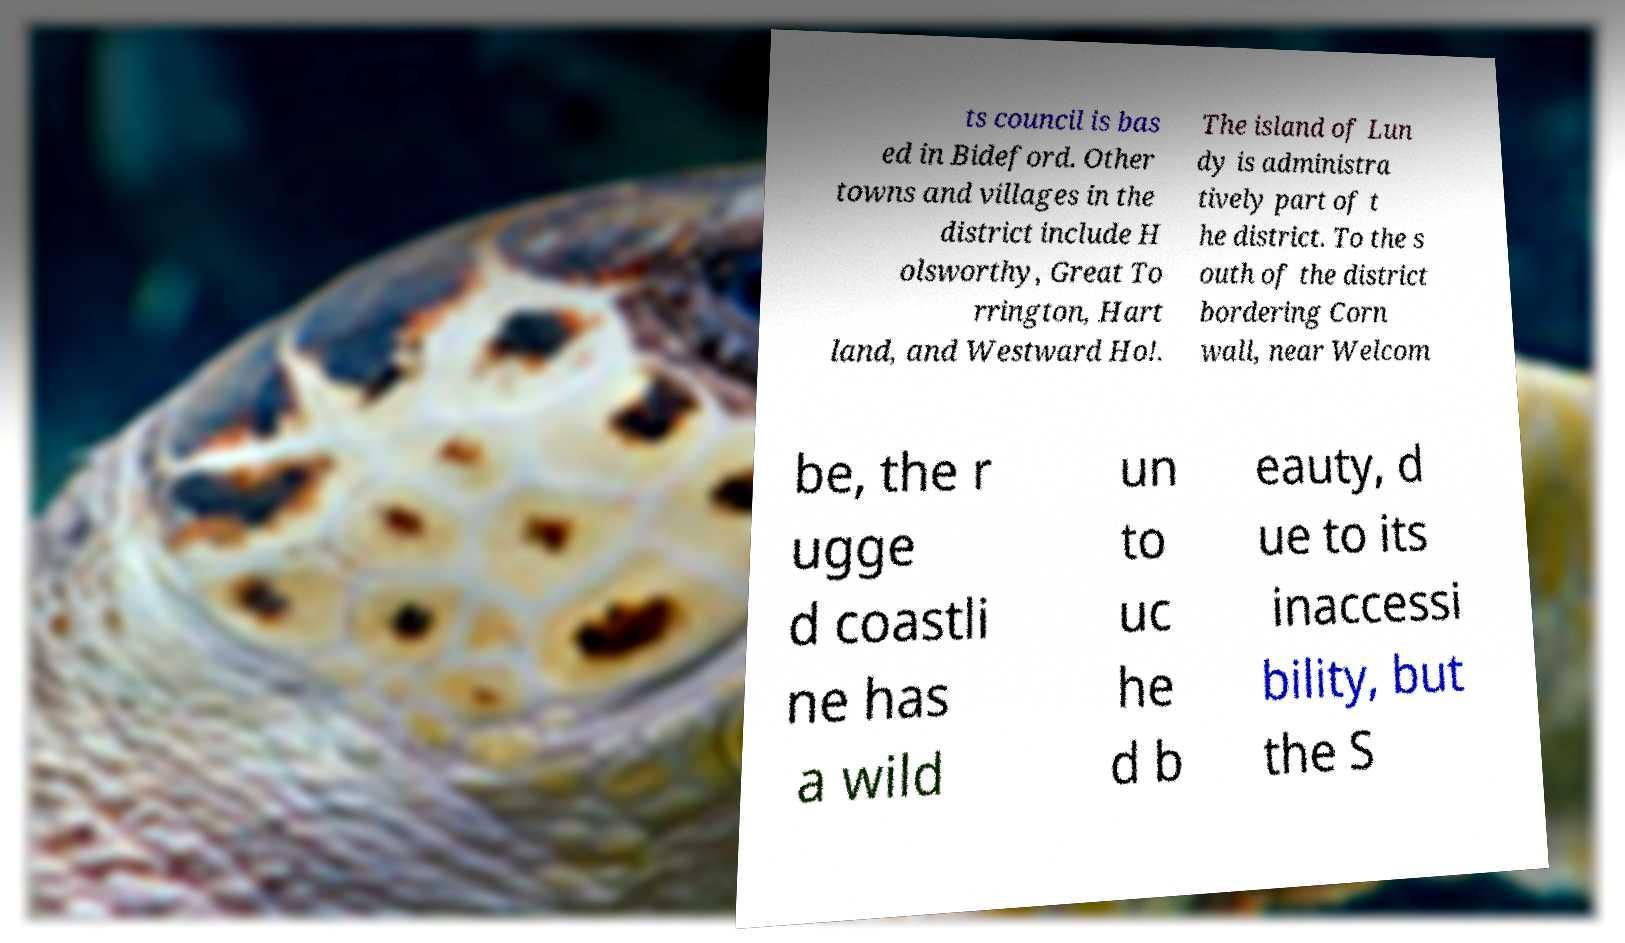What messages or text are displayed in this image? I need them in a readable, typed format. ts council is bas ed in Bideford. Other towns and villages in the district include H olsworthy, Great To rrington, Hart land, and Westward Ho!. The island of Lun dy is administra tively part of t he district. To the s outh of the district bordering Corn wall, near Welcom be, the r ugge d coastli ne has a wild un to uc he d b eauty, d ue to its inaccessi bility, but the S 